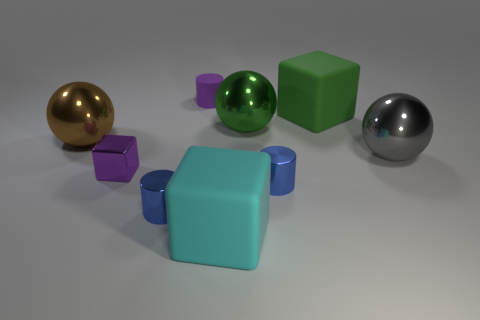How many objects are either small blue metallic cylinders to the left of the cyan matte object or tiny matte cylinders?
Ensure brevity in your answer.  2. What number of objects are cyan spheres or large balls to the right of the tiny purple block?
Make the answer very short. 2. There is a tiny purple block that is behind the big block that is in front of the big brown metal sphere; how many tiny metal cylinders are in front of it?
Make the answer very short. 2. There is a cyan cube that is the same size as the green sphere; what is its material?
Provide a succinct answer. Rubber. Is there a matte cylinder of the same size as the brown object?
Offer a very short reply. No. The shiny cube has what color?
Your response must be concise. Purple. There is a tiny object that is behind the shiny ball that is left of the purple matte object; what is its color?
Ensure brevity in your answer.  Purple. There is a purple thing that is to the right of the purple object that is in front of the cylinder behind the small purple metallic block; what is its shape?
Provide a succinct answer. Cylinder. What number of big cyan objects are the same material as the brown thing?
Provide a short and direct response. 0. There is a tiny cylinder that is behind the small block; how many shiny blocks are left of it?
Keep it short and to the point. 1. 